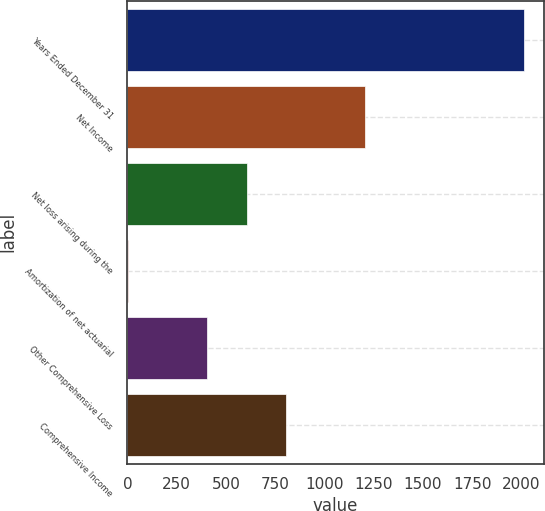<chart> <loc_0><loc_0><loc_500><loc_500><bar_chart><fcel>Years Ended December 31<fcel>Net Income<fcel>Net loss arising during the<fcel>Amortization of net actuarial<fcel>Other Comprehensive Loss<fcel>Comprehensive Income<nl><fcel>2012<fcel>1208<fcel>605<fcel>2<fcel>404<fcel>806<nl></chart> 